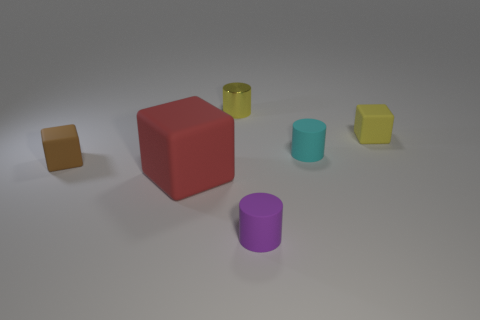Subtract all yellow blocks. How many blocks are left? 2 Add 1 small purple matte balls. How many objects exist? 7 Subtract all purple cylinders. How many cylinders are left? 2 Subtract 1 cylinders. How many cylinders are left? 2 Add 5 tiny shiny cylinders. How many tiny shiny cylinders exist? 6 Subtract 0 red cylinders. How many objects are left? 6 Subtract all blue blocks. Subtract all cyan balls. How many blocks are left? 3 Subtract all purple matte things. Subtract all small yellow metal things. How many objects are left? 4 Add 3 small cyan cylinders. How many small cyan cylinders are left? 4 